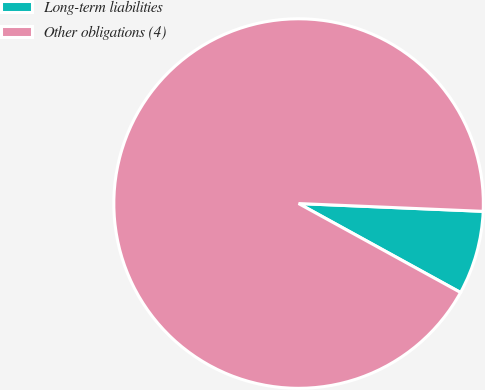<chart> <loc_0><loc_0><loc_500><loc_500><pie_chart><fcel>Long-term liabilities<fcel>Other obligations (4)<nl><fcel>7.32%<fcel>92.68%<nl></chart> 